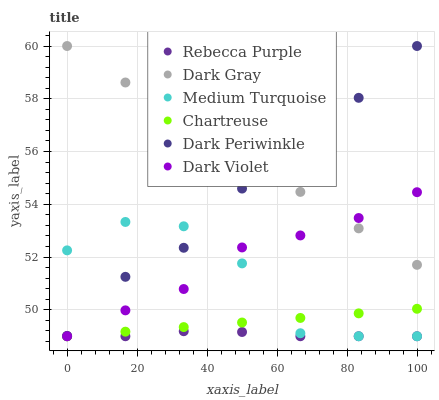Does Rebecca Purple have the minimum area under the curve?
Answer yes or no. Yes. Does Dark Gray have the maximum area under the curve?
Answer yes or no. Yes. Does Chartreuse have the minimum area under the curve?
Answer yes or no. No. Does Chartreuse have the maximum area under the curve?
Answer yes or no. No. Is Dark Gray the smoothest?
Answer yes or no. Yes. Is Medium Turquoise the roughest?
Answer yes or no. Yes. Is Chartreuse the smoothest?
Answer yes or no. No. Is Chartreuse the roughest?
Answer yes or no. No. Does Dark Violet have the lowest value?
Answer yes or no. Yes. Does Dark Gray have the lowest value?
Answer yes or no. No. Does Dark Periwinkle have the highest value?
Answer yes or no. Yes. Does Chartreuse have the highest value?
Answer yes or no. No. Is Dark Violet less than Dark Periwinkle?
Answer yes or no. Yes. Is Dark Periwinkle greater than Rebecca Purple?
Answer yes or no. Yes. Does Dark Violet intersect Rebecca Purple?
Answer yes or no. Yes. Is Dark Violet less than Rebecca Purple?
Answer yes or no. No. Is Dark Violet greater than Rebecca Purple?
Answer yes or no. No. Does Dark Violet intersect Dark Periwinkle?
Answer yes or no. No. 